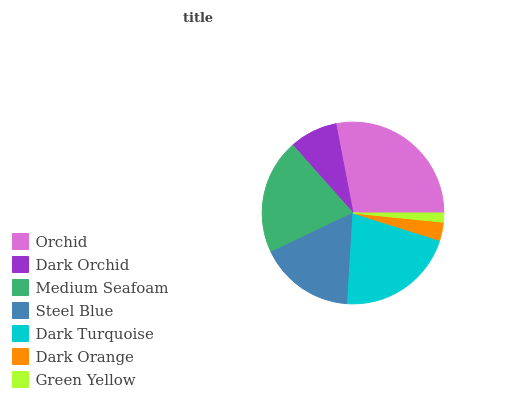Is Green Yellow the minimum?
Answer yes or no. Yes. Is Orchid the maximum?
Answer yes or no. Yes. Is Dark Orchid the minimum?
Answer yes or no. No. Is Dark Orchid the maximum?
Answer yes or no. No. Is Orchid greater than Dark Orchid?
Answer yes or no. Yes. Is Dark Orchid less than Orchid?
Answer yes or no. Yes. Is Dark Orchid greater than Orchid?
Answer yes or no. No. Is Orchid less than Dark Orchid?
Answer yes or no. No. Is Steel Blue the high median?
Answer yes or no. Yes. Is Steel Blue the low median?
Answer yes or no. Yes. Is Orchid the high median?
Answer yes or no. No. Is Orchid the low median?
Answer yes or no. No. 